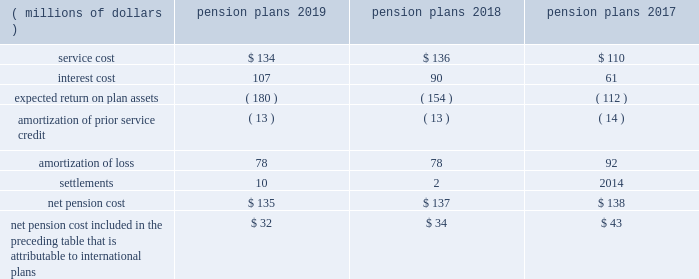Note 9 2014 benefit plans the company has defined benefit pension plans covering certain employees in the united states and certain international locations .
Postretirement healthcare and life insurance benefits provided to qualifying domestic retirees as well as other postretirement benefit plans in international countries are not material .
The measurement date used for the company 2019s employee benefit plans is september 30 .
Effective january 1 , 2018 , the legacy u.s .
Pension plan was frozen to limit the participation of employees who are hired or re-hired by the company , or who transfer employment to the company , on or after january 1 , net pension cost for the years ended september 30 included the following components: .
Net pension cost included in the preceding table that is attributable to international plans $ 32 $ 34 $ 43 the amounts provided above for amortization of prior service credit and amortization of loss represent the reclassifications of prior service credits and net actuarial losses that were recognized in accumulated other comprehensive income ( loss ) in prior periods .
The settlement losses recorded in 2019 and 2018 primarily included lump sum benefit payments associated with the company 2019s u.s .
Supplemental pension plan .
The company recognizes pension settlements when payments from the supplemental plan exceed the sum of service and interest cost components of net periodic pension cost associated with this plan for the fiscal year .
As further discussed in note 2 , upon adopting an accounting standard update on october 1 , 2018 , all components of the company 2019s net periodic pension and postretirement benefit costs , aside from service cost , are recorded to other income ( expense ) , net on its consolidated statements of income , for all periods presented .
Notes to consolidated financial statements 2014 ( continued ) becton , dickinson and company .
What was the average net pension cost from 2017 to 2019 in millions? 
Computations: (((135 + 137) + 138) / 3)
Answer: 136.66667. 